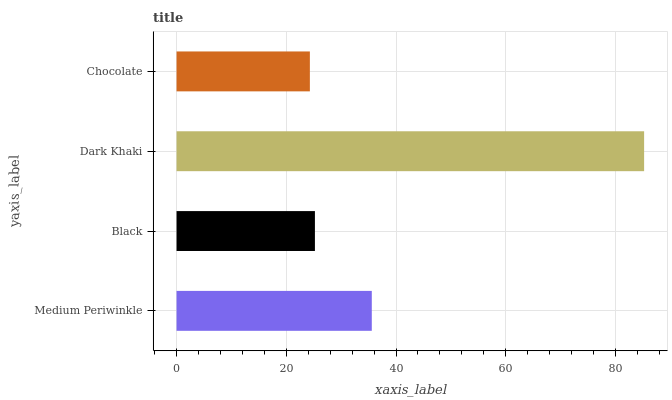Is Chocolate the minimum?
Answer yes or no. Yes. Is Dark Khaki the maximum?
Answer yes or no. Yes. Is Black the minimum?
Answer yes or no. No. Is Black the maximum?
Answer yes or no. No. Is Medium Periwinkle greater than Black?
Answer yes or no. Yes. Is Black less than Medium Periwinkle?
Answer yes or no. Yes. Is Black greater than Medium Periwinkle?
Answer yes or no. No. Is Medium Periwinkle less than Black?
Answer yes or no. No. Is Medium Periwinkle the high median?
Answer yes or no. Yes. Is Black the low median?
Answer yes or no. Yes. Is Black the high median?
Answer yes or no. No. Is Dark Khaki the low median?
Answer yes or no. No. 